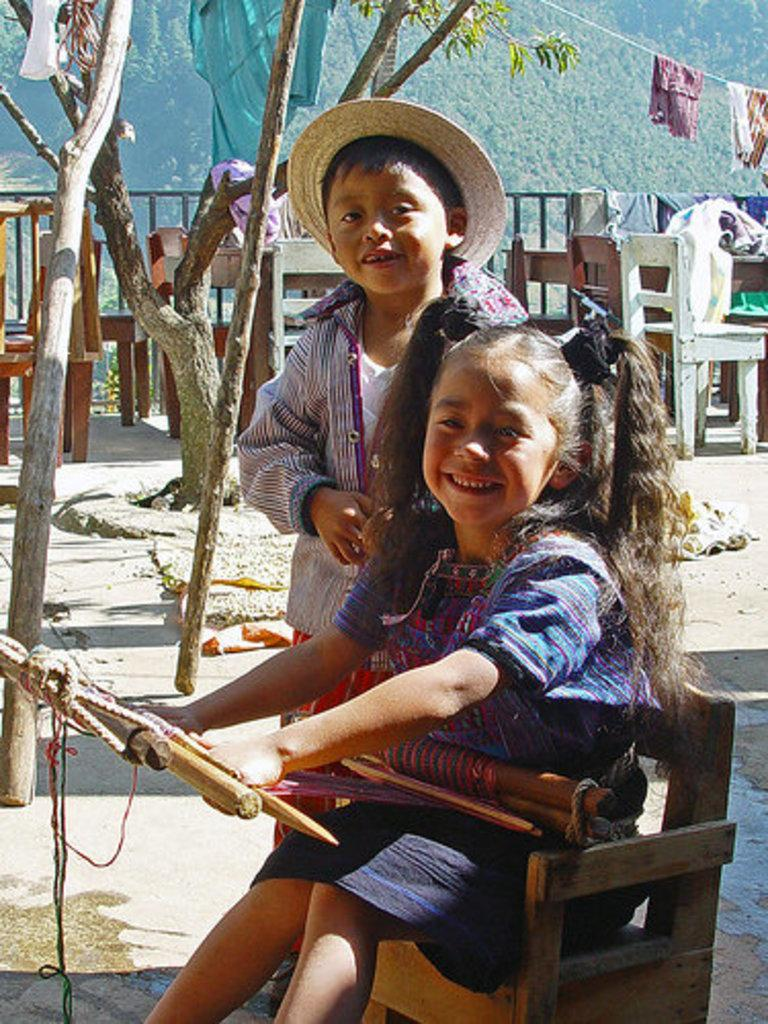How many kids are in the image? There are two kids in the image. What can be seen in the background of the image? There is a rail and trees in the background of the image. What is hanging on the wire in the image? Clothes are hanging on a wire in the image. Where is the grass located in the image? There is no grass visible in the image. What type of tank is present in the image? There is no tank present in the image. 